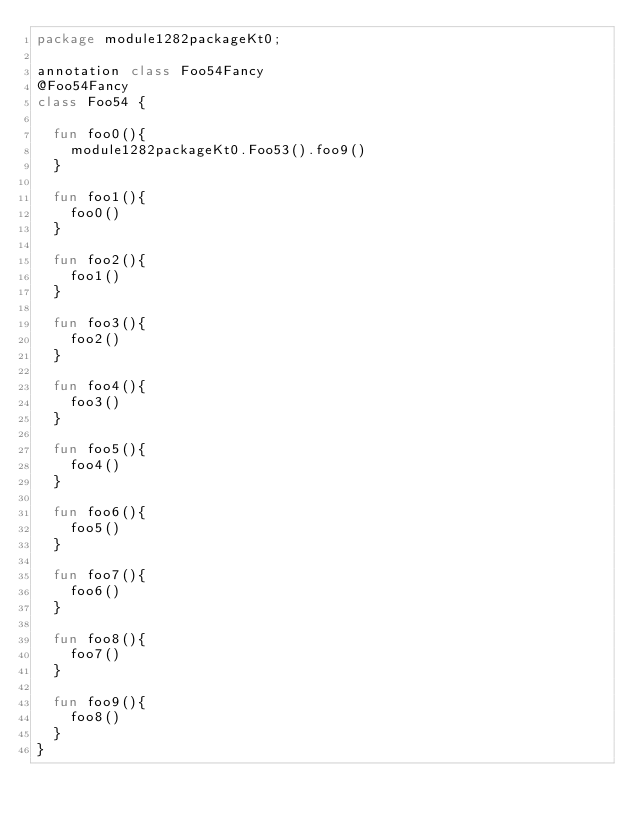Convert code to text. <code><loc_0><loc_0><loc_500><loc_500><_Kotlin_>package module1282packageKt0;

annotation class Foo54Fancy
@Foo54Fancy
class Foo54 {

  fun foo0(){
    module1282packageKt0.Foo53().foo9()
  }

  fun foo1(){
    foo0()
  }

  fun foo2(){
    foo1()
  }

  fun foo3(){
    foo2()
  }

  fun foo4(){
    foo3()
  }

  fun foo5(){
    foo4()
  }

  fun foo6(){
    foo5()
  }

  fun foo7(){
    foo6()
  }

  fun foo8(){
    foo7()
  }

  fun foo9(){
    foo8()
  }
}</code> 